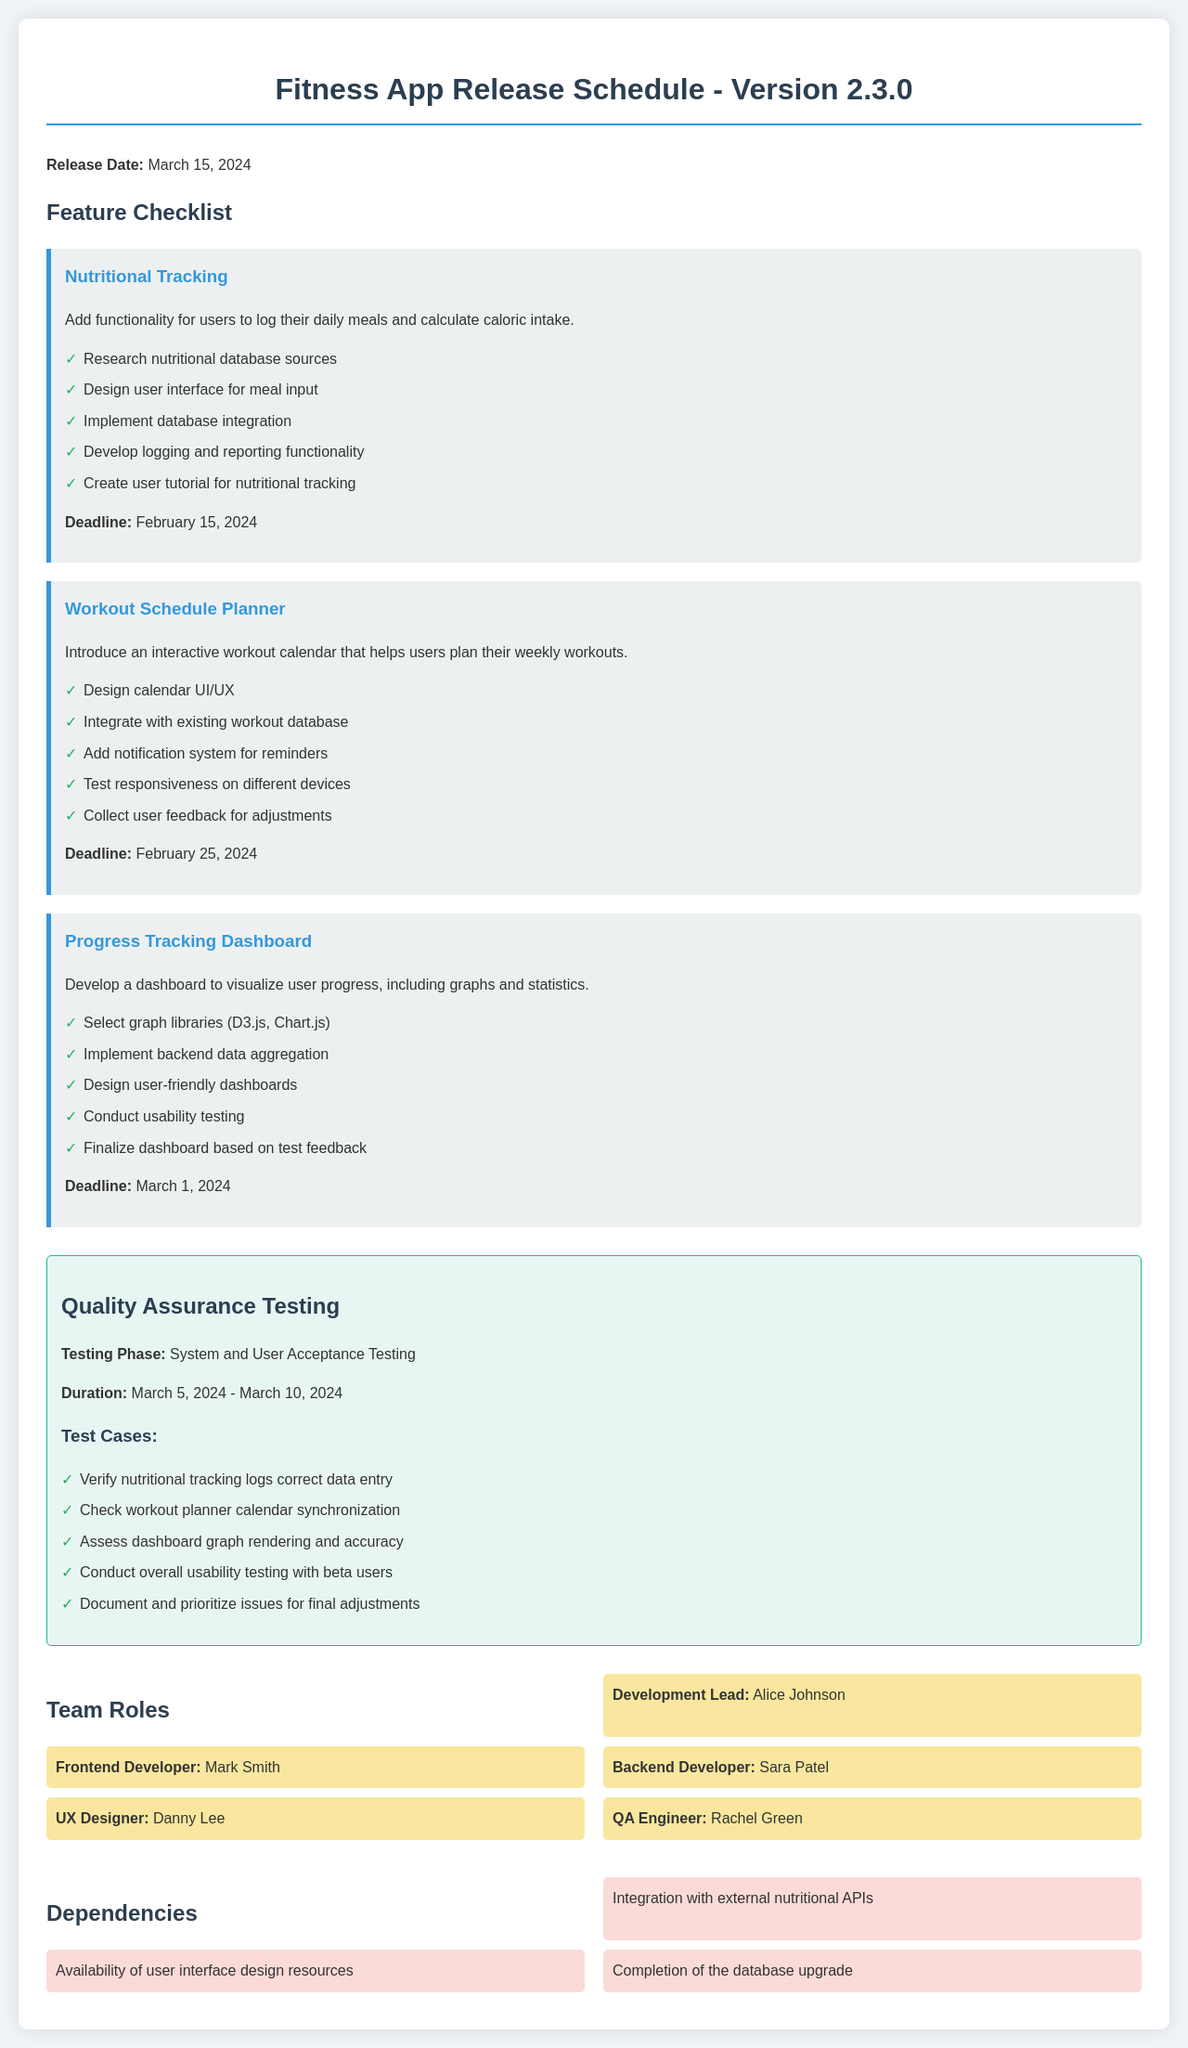What is the release date of version 2.3.0? The release date is specified in the document as March 15, 2024.
Answer: March 15, 2024 What feature deadline is set for Nutritional Tracking? The document lists the deadline for Nutritional Tracking as February 15, 2024.
Answer: February 15, 2024 Who is the Development Lead? The document identifies Alice Johnson as the Development Lead.
Answer: Alice Johnson How many test cases are listed for Quality Assurance Testing? There are five test cases provided in the QA Testing section of the document.
Answer: 5 What is the duration of the Quality Assurance Testing phase? The duration for QA Testing is outlined as March 5, 2024, to March 10, 2024.
Answer: March 5, 2024 - March 10, 2024 Which feature includes the implementation of a notification system? The Workout Schedule Planner feature includes adding a notification system for reminders.
Answer: Workout Schedule Planner What dependencies are mentioned in the document? The three dependencies listed are integration with external nutritional APIs, availability of user interface design resources, and completion of the database upgrade.
Answer: Integration with external nutritional APIs, availability of user interface design resources, completion of the database upgrade How many team roles are detailed in the document? The document provides a total of five different team roles.
Answer: 5 What is a key functionality of the Progress Tracking Dashboard? A key functionality is to visualize user progress, including graphs and statistics.
Answer: Visualize user progress, including graphs and statistics 